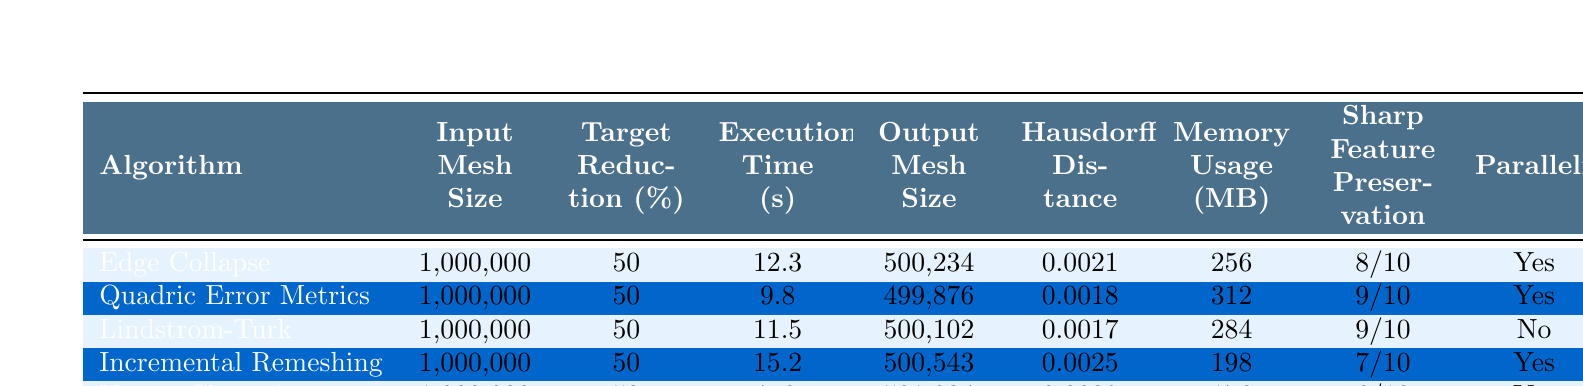What is the execution time of the Quadric Error Metrics algorithm? The execution time for the Quadric Error Metrics algorithm is listed in the table under "Execution Time (s)." It shows a value of 9.8 seconds.
Answer: 9.8 seconds Which algorithm has the highest memory usage? To find the highest memory usage, I can compare the values in the "Memory Usage (MB)" column. The maximum value noted is 312 MB, which corresponds to the Quadric Error Metrics algorithm.
Answer: Quadric Error Metrics What is the Hausdorff Distance of the Edge Collapse algorithm? The Hausdorff Distance for the Edge Collapse algorithm can be located under the "Hausdorff Distance" column, where it shows a value of 0.0021.
Answer: 0.0021 How many algorithms support parallelization? To determine the number of algorithms that support parallelization, I need to count the occurrences of "Yes" in the "Parallelization Support" column. There are four algorithms that support parallelization.
Answer: 4 What is the difference in execution time between Vertex Clustering and Incremental Remeshing? The execution time for Vertex Clustering is 7.6 seconds, and for Incremental Remeshing, it is 15.2 seconds. To find the difference, I subtract the former from the latter: 15.2 - 7.6 = 7.6 seconds.
Answer: 7.6 seconds Which algorithm preserves sharp features the best? The "Preservation of Sharp Features (1-10)" column is where I can find sharp feature preservation ratings. The highest score is 9/10, which corresponds to both Quadric Error Metrics and Lindstrom-Turk algorithms.
Answer: Quadric Error Metrics and Lindstrom-Turk What is the average execution time of all algorithms? I can calculate the average execution time by summing all execution times (12.3 + 9.8 + 11.5 + 15.2 + 7.6) which equals 56.4 seconds. I then divide it by the number of algorithms (5) to get the average: 56.4 / 5 = 11.28 seconds.
Answer: 11.28 seconds Which algorithm has the smallest output mesh size? By checking the "Output Mesh Size (vertices)" column, I can see that the Quadric Error Metrics algorithm has the smallest output size at 499,876 vertices.
Answer: Quadric Error Metrics Is the Hausdorff Distance greater for Incremental Remeshing than for Vertex Clustering? I can compare the Hausdorff Distances listed: Incremental Remeshing has a distance of 0.0025, while Vertex Clustering has 0.0032. Since 0.0032 is greater than 0.0025, the statement is true.
Answer: Yes What is the minimum memory usage among the algorithms? The minimum memory usage can be found in the "Memory Usage (MB)" column by identifying the smallest value, which is 176 MB for the Vertex Clustering algorithm.
Answer: 176 MB 